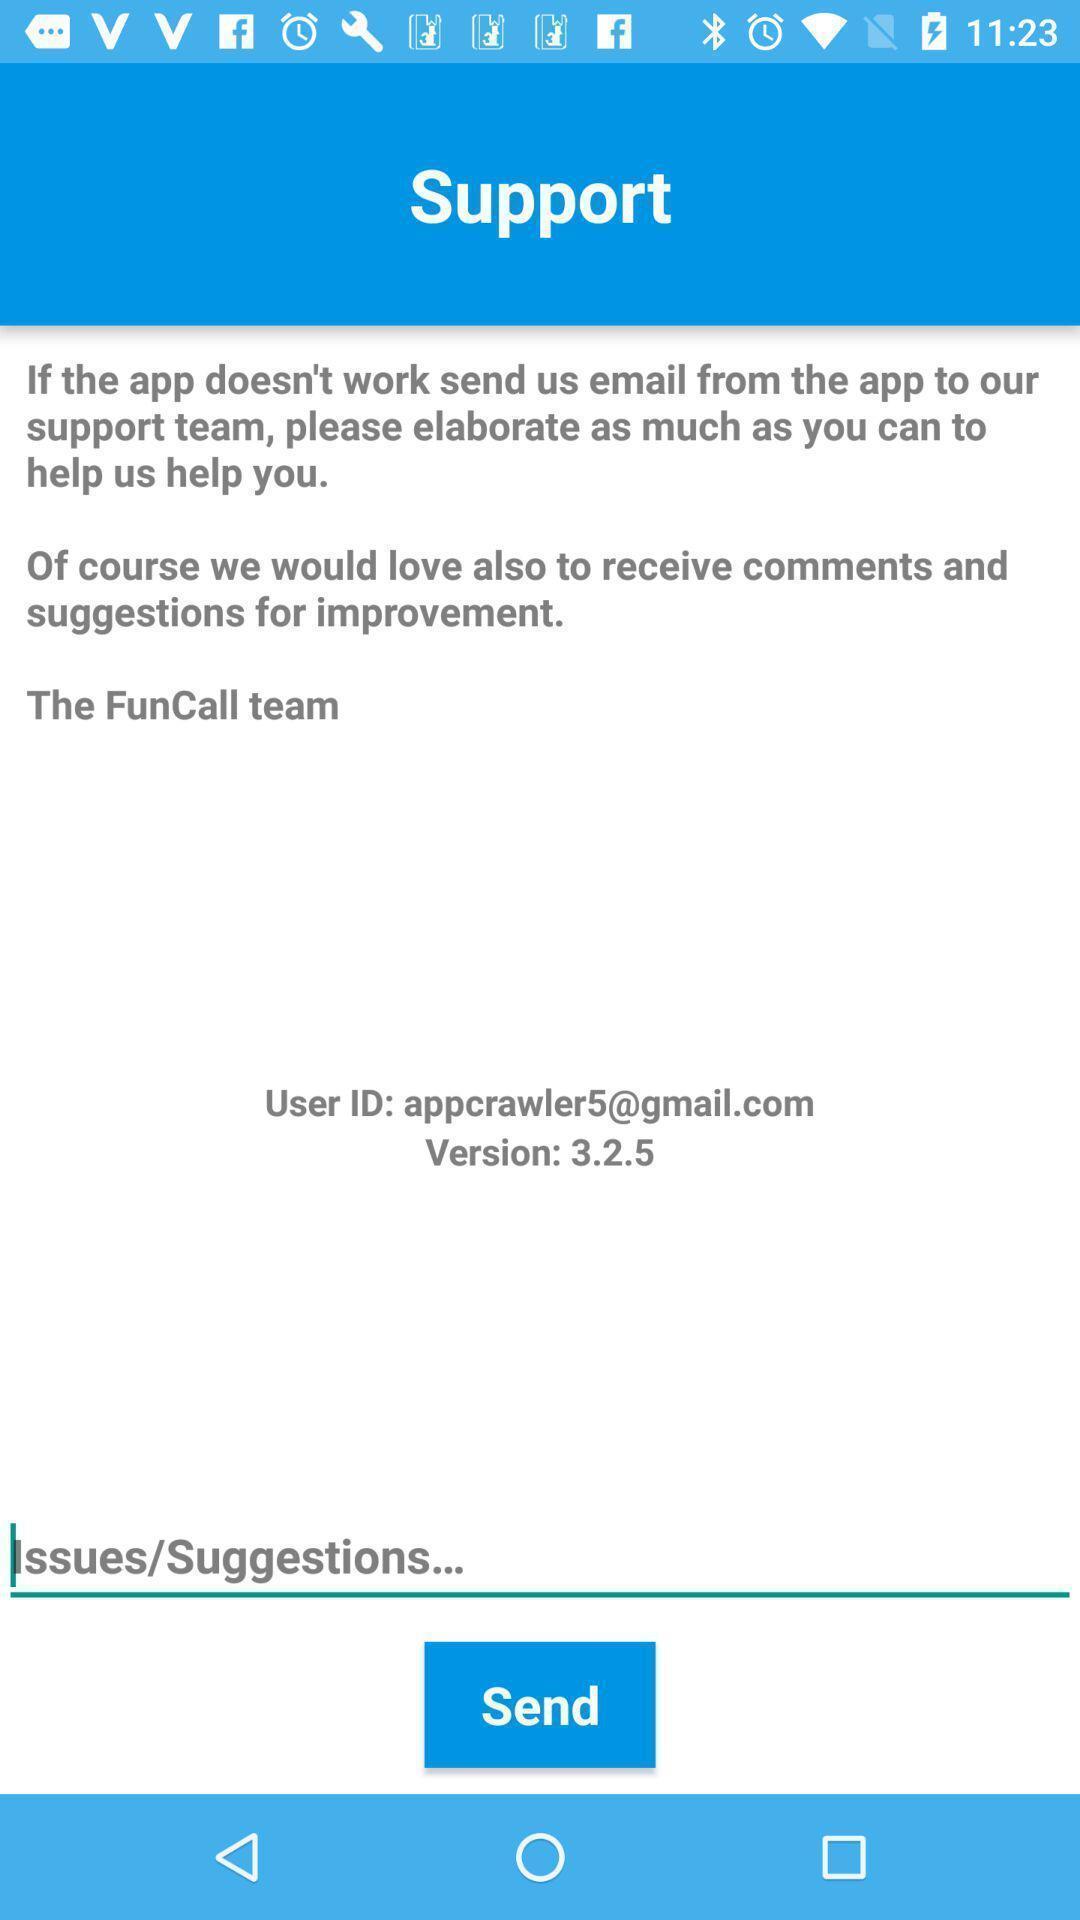What details can you identify in this image? Support page with an information of application. 